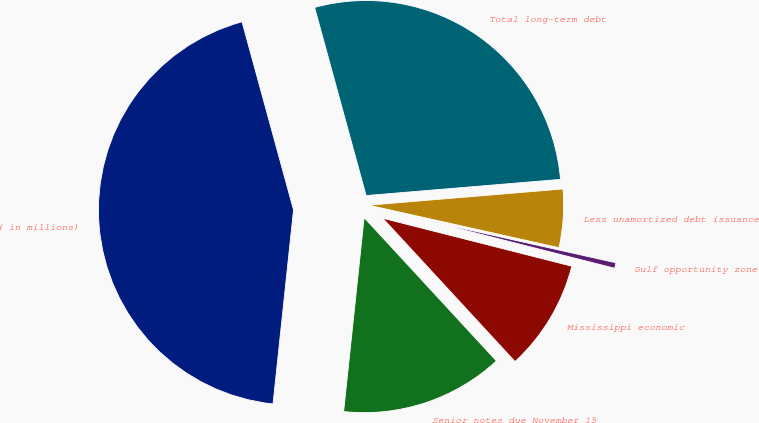Convert chart to OTSL. <chart><loc_0><loc_0><loc_500><loc_500><pie_chart><fcel>( in millions)<fcel>Senior notes due November 15<fcel>Mississippi economic<fcel>Gulf opportunity zone<fcel>Less unamortized debt issuance<fcel>Total long-term debt<nl><fcel>44.07%<fcel>13.54%<fcel>9.18%<fcel>0.46%<fcel>4.82%<fcel>27.93%<nl></chart> 